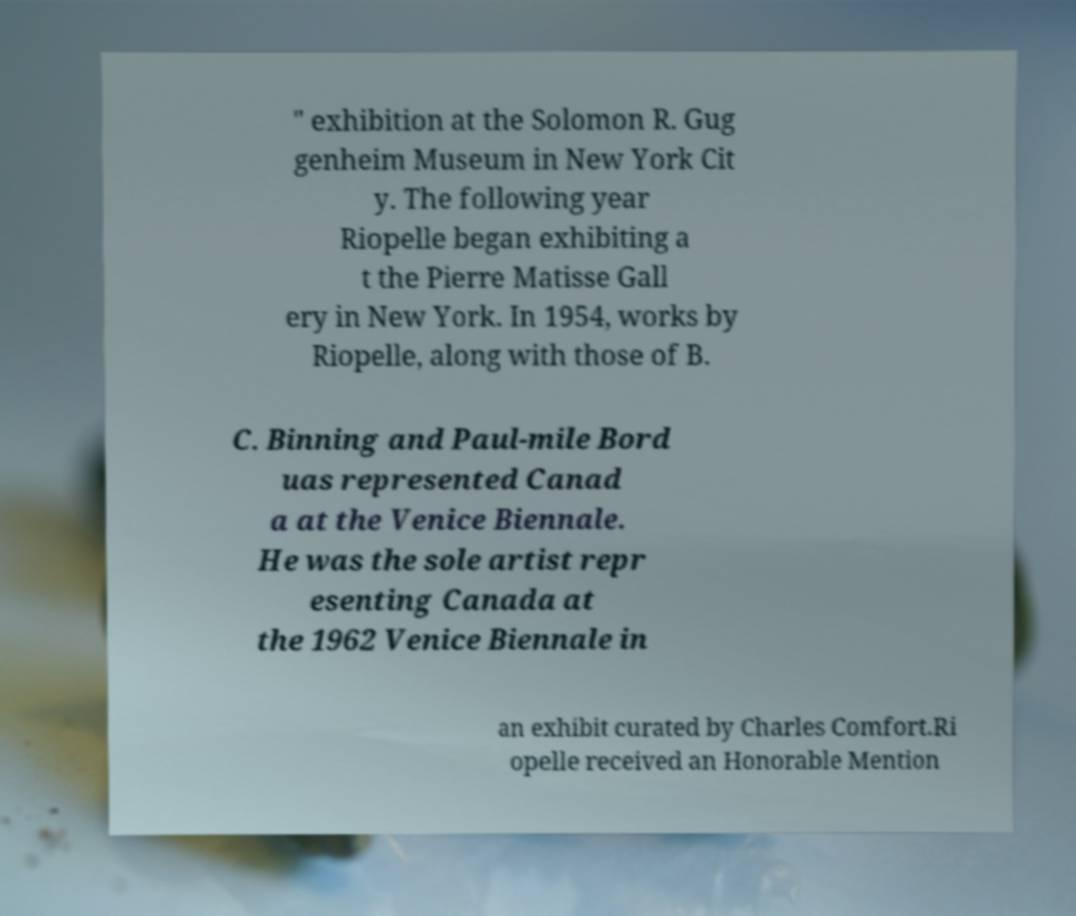Could you assist in decoding the text presented in this image and type it out clearly? " exhibition at the Solomon R. Gug genheim Museum in New York Cit y. The following year Riopelle began exhibiting a t the Pierre Matisse Gall ery in New York. In 1954, works by Riopelle, along with those of B. C. Binning and Paul-mile Bord uas represented Canad a at the Venice Biennale. He was the sole artist repr esenting Canada at the 1962 Venice Biennale in an exhibit curated by Charles Comfort.Ri opelle received an Honorable Mention 